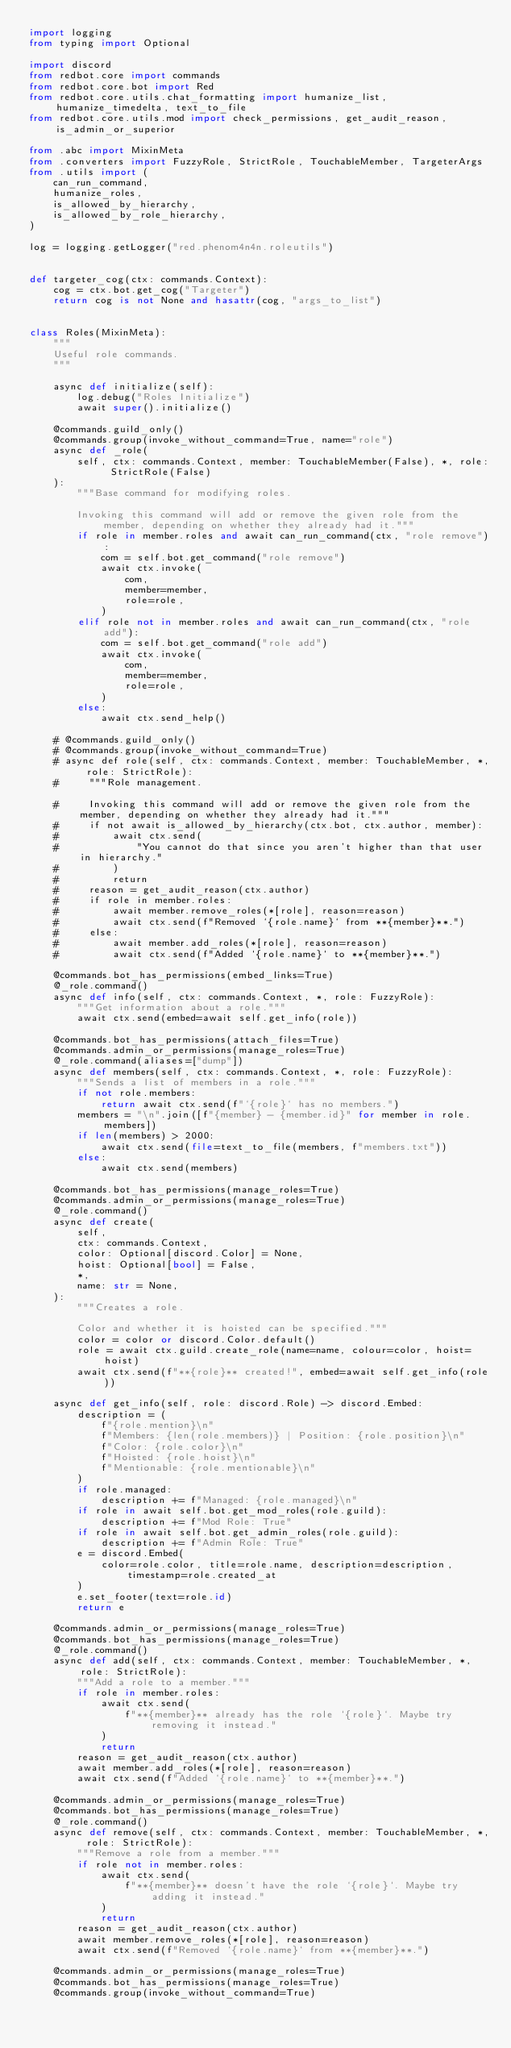Convert code to text. <code><loc_0><loc_0><loc_500><loc_500><_Python_>import logging
from typing import Optional

import discord
from redbot.core import commands
from redbot.core.bot import Red
from redbot.core.utils.chat_formatting import humanize_list, humanize_timedelta, text_to_file
from redbot.core.utils.mod import check_permissions, get_audit_reason, is_admin_or_superior

from .abc import MixinMeta
from .converters import FuzzyRole, StrictRole, TouchableMember, TargeterArgs
from .utils import (
    can_run_command,
    humanize_roles,
    is_allowed_by_hierarchy,
    is_allowed_by_role_hierarchy,
)

log = logging.getLogger("red.phenom4n4n.roleutils")


def targeter_cog(ctx: commands.Context):
    cog = ctx.bot.get_cog("Targeter")
    return cog is not None and hasattr(cog, "args_to_list")


class Roles(MixinMeta):
    """
    Useful role commands.
    """

    async def initialize(self):
        log.debug("Roles Initialize")
        await super().initialize()

    @commands.guild_only()
    @commands.group(invoke_without_command=True, name="role")
    async def _role(
        self, ctx: commands.Context, member: TouchableMember(False), *, role: StrictRole(False)
    ):
        """Base command for modifying roles.

        Invoking this command will add or remove the given role from the member, depending on whether they already had it."""
        if role in member.roles and await can_run_command(ctx, "role remove"):
            com = self.bot.get_command("role remove")
            await ctx.invoke(
                com,
                member=member,
                role=role,
            )
        elif role not in member.roles and await can_run_command(ctx, "role add"):
            com = self.bot.get_command("role add")
            await ctx.invoke(
                com,
                member=member,
                role=role,
            )
        else:
            await ctx.send_help()

    # @commands.guild_only()
    # @commands.group(invoke_without_command=True)
    # async def role(self, ctx: commands.Context, member: TouchableMember, *, role: StrictRole):
    #     """Role management.

    #     Invoking this command will add or remove the given role from the member, depending on whether they already had it."""
    #     if not await is_allowed_by_hierarchy(ctx.bot, ctx.author, member):
    #         await ctx.send(
    #             "You cannot do that since you aren't higher than that user in hierarchy."
    #         )
    #         return
    #     reason = get_audit_reason(ctx.author)
    #     if role in member.roles:
    #         await member.remove_roles(*[role], reason=reason)
    #         await ctx.send(f"Removed `{role.name}` from **{member}**.")
    #     else:
    #         await member.add_roles(*[role], reason=reason)
    #         await ctx.send(f"Added `{role.name}` to **{member}**.")

    @commands.bot_has_permissions(embed_links=True)
    @_role.command()
    async def info(self, ctx: commands.Context, *, role: FuzzyRole):
        """Get information about a role."""
        await ctx.send(embed=await self.get_info(role))

    @commands.bot_has_permissions(attach_files=True)
    @commands.admin_or_permissions(manage_roles=True)
    @_role.command(aliases=["dump"])
    async def members(self, ctx: commands.Context, *, role: FuzzyRole):
        """Sends a list of members in a role."""
        if not role.members:
            return await ctx.send(f"`{role}` has no members.")
        members = "\n".join([f"{member} - {member.id}" for member in role.members])
        if len(members) > 2000:
            await ctx.send(file=text_to_file(members, f"members.txt"))
        else:
            await ctx.send(members)

    @commands.bot_has_permissions(manage_roles=True)
    @commands.admin_or_permissions(manage_roles=True)
    @_role.command()
    async def create(
        self,
        ctx: commands.Context,
        color: Optional[discord.Color] = None,
        hoist: Optional[bool] = False,
        *,
        name: str = None,
    ):
        """Creates a role.

        Color and whether it is hoisted can be specified."""
        color = color or discord.Color.default()
        role = await ctx.guild.create_role(name=name, colour=color, hoist=hoist)
        await ctx.send(f"**{role}** created!", embed=await self.get_info(role))

    async def get_info(self, role: discord.Role) -> discord.Embed:
        description = (
            f"{role.mention}\n"
            f"Members: {len(role.members)} | Position: {role.position}\n"
            f"Color: {role.color}\n"
            f"Hoisted: {role.hoist}\n"
            f"Mentionable: {role.mentionable}\n"
        )
        if role.managed:
            description += f"Managed: {role.managed}\n"
        if role in await self.bot.get_mod_roles(role.guild):
            description += f"Mod Role: True"
        if role in await self.bot.get_admin_roles(role.guild):
            description += f"Admin Role: True"
        e = discord.Embed(
            color=role.color, title=role.name, description=description, timestamp=role.created_at
        )
        e.set_footer(text=role.id)
        return e

    @commands.admin_or_permissions(manage_roles=True)
    @commands.bot_has_permissions(manage_roles=True)
    @_role.command()
    async def add(self, ctx: commands.Context, member: TouchableMember, *, role: StrictRole):
        """Add a role to a member."""
        if role in member.roles:
            await ctx.send(
                f"**{member}** already has the role `{role}`. Maybe try removing it instead."
            )
            return
        reason = get_audit_reason(ctx.author)
        await member.add_roles(*[role], reason=reason)
        await ctx.send(f"Added `{role.name}` to **{member}**.")

    @commands.admin_or_permissions(manage_roles=True)
    @commands.bot_has_permissions(manage_roles=True)
    @_role.command()
    async def remove(self, ctx: commands.Context, member: TouchableMember, *, role: StrictRole):
        """Remove a role from a member."""
        if role not in member.roles:
            await ctx.send(
                f"**{member}** doesn't have the role `{role}`. Maybe try adding it instead."
            )
            return
        reason = get_audit_reason(ctx.author)
        await member.remove_roles(*[role], reason=reason)
        await ctx.send(f"Removed `{role.name}` from **{member}**.")

    @commands.admin_or_permissions(manage_roles=True)
    @commands.bot_has_permissions(manage_roles=True)
    @commands.group(invoke_without_command=True)</code> 